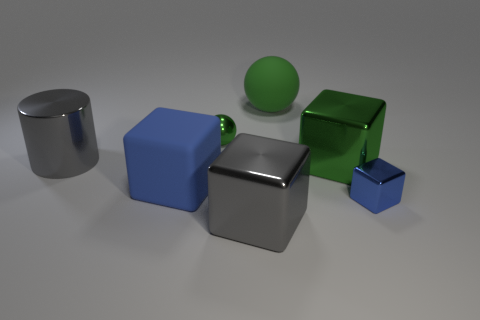Add 2 big green matte cubes. How many objects exist? 9 Subtract all cylinders. How many objects are left? 6 Subtract all large green objects. Subtract all small blue metallic things. How many objects are left? 4 Add 7 blue things. How many blue things are left? 9 Add 6 green rubber cylinders. How many green rubber cylinders exist? 6 Subtract 0 purple cylinders. How many objects are left? 7 